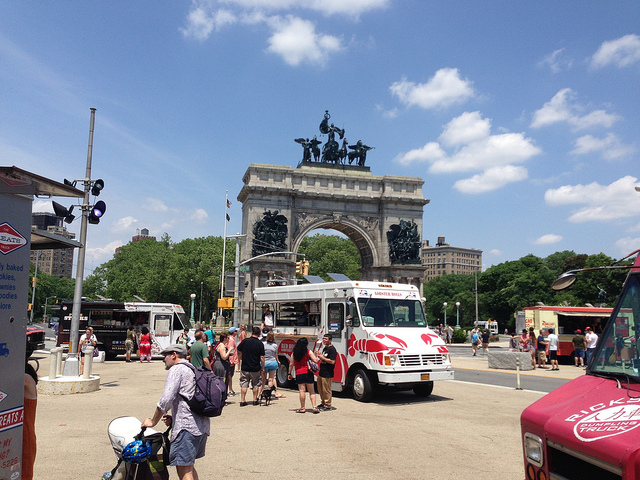Describe the historical significance of the monument. The monument in the image is reminiscent of the classical triumphal arches often erected to celebrate military victories or significant historical events. The sculptures atop the arch likely symbolize themes of victory or heroism. This particular monument could be a tribute to an important event or figure in the region's history, serving as a constant reminder of past glories and the cultural heritage of the area. What are some activities people might be engaging in around the monument based on the image? Judging by the image, people seem to be enjoying a variety of activities around the monument. Some are likely indulging in food from the nearby food trucks, while others may be tourists taking photographs or simply admiring the architecture. Families with children and strollers suggest that this is a popular spot for a leisurely outing. The presence of backpacks and casual attire indicates that visitors might be exploring the surrounding areas or engaging in social interactions. 